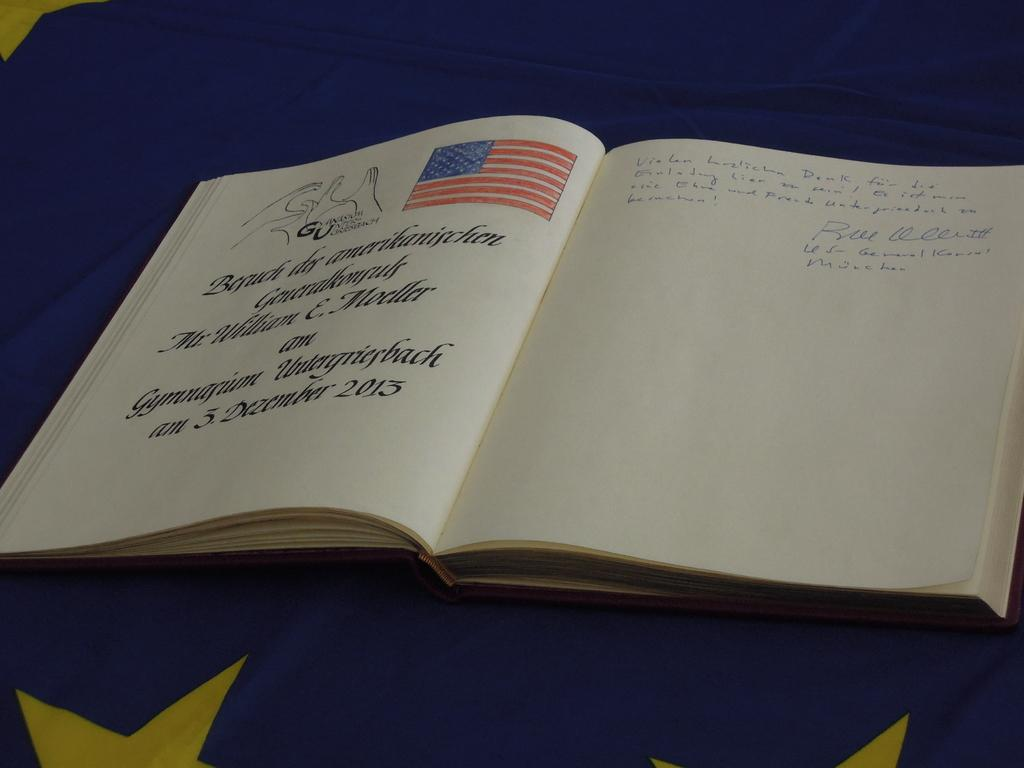<image>
Summarize the visual content of the image. A book is open to a page with an American page and says 3 December 2013. 